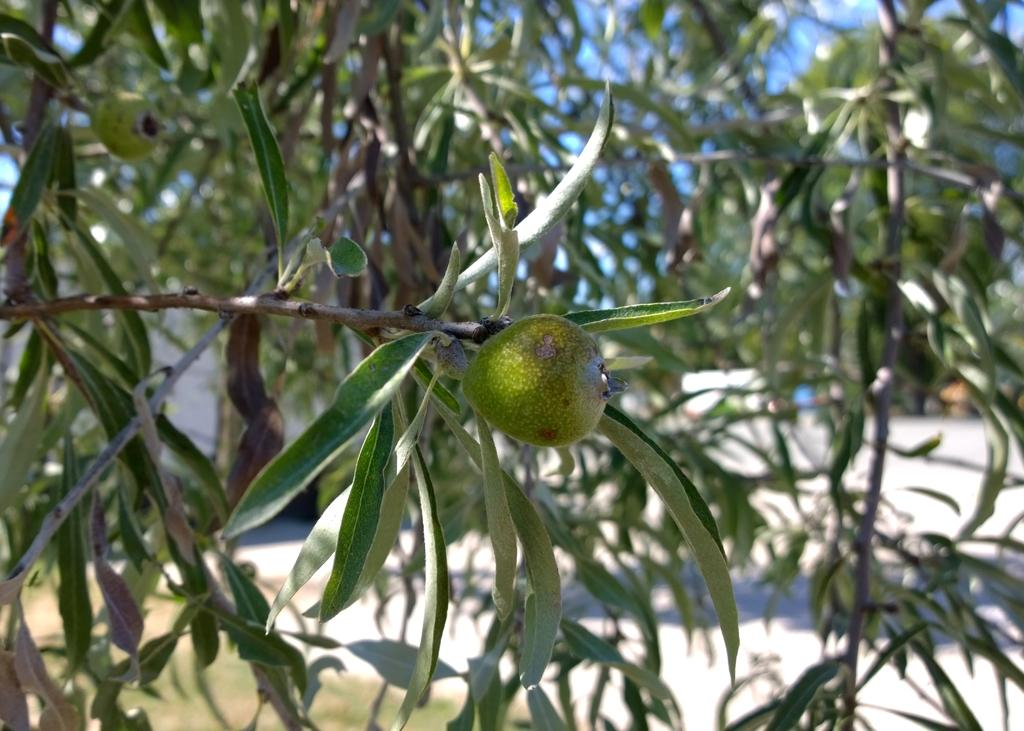What is the main subject in the middle of the picture? There is a tree with green color fruit in the picture. Where is the tree located in the picture? The tree is in the middle of the picture. What can be seen in the background of the picture? There are trees and the sky visible in the background of the picture. What type of cover is used to protect the tree during the vacation? There is no mention of a vacation or any protective cover for the tree in the image. 